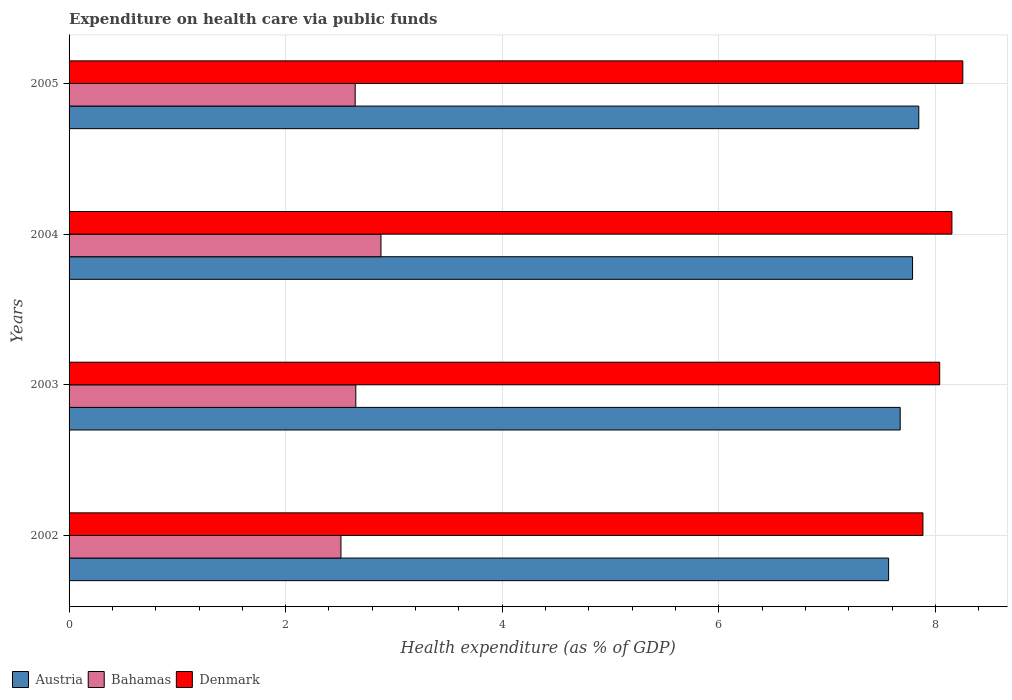How many groups of bars are there?
Give a very brief answer. 4. Are the number of bars per tick equal to the number of legend labels?
Make the answer very short. Yes. Are the number of bars on each tick of the Y-axis equal?
Ensure brevity in your answer.  Yes. How many bars are there on the 4th tick from the bottom?
Your answer should be very brief. 3. In how many cases, is the number of bars for a given year not equal to the number of legend labels?
Make the answer very short. 0. What is the expenditure made on health care in Denmark in 2002?
Offer a terse response. 7.89. Across all years, what is the maximum expenditure made on health care in Austria?
Your answer should be compact. 7.85. Across all years, what is the minimum expenditure made on health care in Denmark?
Provide a succinct answer. 7.89. In which year was the expenditure made on health care in Denmark minimum?
Provide a succinct answer. 2002. What is the total expenditure made on health care in Bahamas in the graph?
Your answer should be very brief. 10.68. What is the difference between the expenditure made on health care in Bahamas in 2004 and that in 2005?
Provide a succinct answer. 0.24. What is the difference between the expenditure made on health care in Bahamas in 2004 and the expenditure made on health care in Denmark in 2002?
Your response must be concise. -5. What is the average expenditure made on health care in Denmark per year?
Your answer should be very brief. 8.08. In the year 2005, what is the difference between the expenditure made on health care in Denmark and expenditure made on health care in Austria?
Your answer should be compact. 0.41. What is the ratio of the expenditure made on health care in Austria in 2002 to that in 2004?
Ensure brevity in your answer.  0.97. Is the expenditure made on health care in Denmark in 2002 less than that in 2005?
Your response must be concise. Yes. What is the difference between the highest and the second highest expenditure made on health care in Denmark?
Offer a very short reply. 0.1. What is the difference between the highest and the lowest expenditure made on health care in Denmark?
Provide a short and direct response. 0.37. What does the 2nd bar from the top in 2005 represents?
Your answer should be compact. Bahamas. What does the 2nd bar from the bottom in 2005 represents?
Keep it short and to the point. Bahamas. Is it the case that in every year, the sum of the expenditure made on health care in Denmark and expenditure made on health care in Bahamas is greater than the expenditure made on health care in Austria?
Your answer should be very brief. Yes. What is the difference between two consecutive major ticks on the X-axis?
Ensure brevity in your answer.  2. Are the values on the major ticks of X-axis written in scientific E-notation?
Your response must be concise. No. Does the graph contain grids?
Your answer should be very brief. Yes. Where does the legend appear in the graph?
Make the answer very short. Bottom left. How many legend labels are there?
Your answer should be very brief. 3. How are the legend labels stacked?
Keep it short and to the point. Horizontal. What is the title of the graph?
Give a very brief answer. Expenditure on health care via public funds. What is the label or title of the X-axis?
Offer a very short reply. Health expenditure (as % of GDP). What is the Health expenditure (as % of GDP) of Austria in 2002?
Give a very brief answer. 7.57. What is the Health expenditure (as % of GDP) of Bahamas in 2002?
Offer a terse response. 2.51. What is the Health expenditure (as % of GDP) of Denmark in 2002?
Offer a terse response. 7.89. What is the Health expenditure (as % of GDP) of Austria in 2003?
Your answer should be compact. 7.68. What is the Health expenditure (as % of GDP) in Bahamas in 2003?
Your answer should be very brief. 2.65. What is the Health expenditure (as % of GDP) of Denmark in 2003?
Ensure brevity in your answer.  8.04. What is the Health expenditure (as % of GDP) of Austria in 2004?
Your answer should be compact. 7.79. What is the Health expenditure (as % of GDP) in Bahamas in 2004?
Ensure brevity in your answer.  2.88. What is the Health expenditure (as % of GDP) of Denmark in 2004?
Your response must be concise. 8.15. What is the Health expenditure (as % of GDP) in Austria in 2005?
Make the answer very short. 7.85. What is the Health expenditure (as % of GDP) in Bahamas in 2005?
Keep it short and to the point. 2.64. What is the Health expenditure (as % of GDP) of Denmark in 2005?
Your answer should be very brief. 8.25. Across all years, what is the maximum Health expenditure (as % of GDP) in Austria?
Provide a short and direct response. 7.85. Across all years, what is the maximum Health expenditure (as % of GDP) in Bahamas?
Make the answer very short. 2.88. Across all years, what is the maximum Health expenditure (as % of GDP) of Denmark?
Offer a terse response. 8.25. Across all years, what is the minimum Health expenditure (as % of GDP) of Austria?
Give a very brief answer. 7.57. Across all years, what is the minimum Health expenditure (as % of GDP) in Bahamas?
Ensure brevity in your answer.  2.51. Across all years, what is the minimum Health expenditure (as % of GDP) in Denmark?
Provide a short and direct response. 7.89. What is the total Health expenditure (as % of GDP) of Austria in the graph?
Your response must be concise. 30.88. What is the total Health expenditure (as % of GDP) in Bahamas in the graph?
Make the answer very short. 10.68. What is the total Health expenditure (as % of GDP) in Denmark in the graph?
Your answer should be very brief. 32.33. What is the difference between the Health expenditure (as % of GDP) in Austria in 2002 and that in 2003?
Your answer should be very brief. -0.11. What is the difference between the Health expenditure (as % of GDP) of Bahamas in 2002 and that in 2003?
Offer a very short reply. -0.14. What is the difference between the Health expenditure (as % of GDP) in Denmark in 2002 and that in 2003?
Provide a short and direct response. -0.15. What is the difference between the Health expenditure (as % of GDP) of Austria in 2002 and that in 2004?
Offer a very short reply. -0.22. What is the difference between the Health expenditure (as % of GDP) of Bahamas in 2002 and that in 2004?
Ensure brevity in your answer.  -0.37. What is the difference between the Health expenditure (as % of GDP) in Denmark in 2002 and that in 2004?
Your answer should be very brief. -0.27. What is the difference between the Health expenditure (as % of GDP) of Austria in 2002 and that in 2005?
Keep it short and to the point. -0.28. What is the difference between the Health expenditure (as % of GDP) in Bahamas in 2002 and that in 2005?
Provide a short and direct response. -0.13. What is the difference between the Health expenditure (as % of GDP) of Denmark in 2002 and that in 2005?
Your response must be concise. -0.37. What is the difference between the Health expenditure (as % of GDP) of Austria in 2003 and that in 2004?
Provide a short and direct response. -0.11. What is the difference between the Health expenditure (as % of GDP) in Bahamas in 2003 and that in 2004?
Offer a terse response. -0.23. What is the difference between the Health expenditure (as % of GDP) of Denmark in 2003 and that in 2004?
Offer a very short reply. -0.11. What is the difference between the Health expenditure (as % of GDP) in Austria in 2003 and that in 2005?
Offer a terse response. -0.17. What is the difference between the Health expenditure (as % of GDP) of Bahamas in 2003 and that in 2005?
Provide a short and direct response. 0.01. What is the difference between the Health expenditure (as % of GDP) of Denmark in 2003 and that in 2005?
Make the answer very short. -0.21. What is the difference between the Health expenditure (as % of GDP) in Austria in 2004 and that in 2005?
Give a very brief answer. -0.06. What is the difference between the Health expenditure (as % of GDP) of Bahamas in 2004 and that in 2005?
Your response must be concise. 0.24. What is the difference between the Health expenditure (as % of GDP) of Denmark in 2004 and that in 2005?
Give a very brief answer. -0.1. What is the difference between the Health expenditure (as % of GDP) of Austria in 2002 and the Health expenditure (as % of GDP) of Bahamas in 2003?
Offer a terse response. 4.92. What is the difference between the Health expenditure (as % of GDP) in Austria in 2002 and the Health expenditure (as % of GDP) in Denmark in 2003?
Provide a succinct answer. -0.47. What is the difference between the Health expenditure (as % of GDP) of Bahamas in 2002 and the Health expenditure (as % of GDP) of Denmark in 2003?
Provide a succinct answer. -5.53. What is the difference between the Health expenditure (as % of GDP) in Austria in 2002 and the Health expenditure (as % of GDP) in Bahamas in 2004?
Your response must be concise. 4.69. What is the difference between the Health expenditure (as % of GDP) in Austria in 2002 and the Health expenditure (as % of GDP) in Denmark in 2004?
Give a very brief answer. -0.58. What is the difference between the Health expenditure (as % of GDP) of Bahamas in 2002 and the Health expenditure (as % of GDP) of Denmark in 2004?
Offer a terse response. -5.64. What is the difference between the Health expenditure (as % of GDP) of Austria in 2002 and the Health expenditure (as % of GDP) of Bahamas in 2005?
Provide a short and direct response. 4.93. What is the difference between the Health expenditure (as % of GDP) of Austria in 2002 and the Health expenditure (as % of GDP) of Denmark in 2005?
Make the answer very short. -0.69. What is the difference between the Health expenditure (as % of GDP) in Bahamas in 2002 and the Health expenditure (as % of GDP) in Denmark in 2005?
Keep it short and to the point. -5.74. What is the difference between the Health expenditure (as % of GDP) of Austria in 2003 and the Health expenditure (as % of GDP) of Bahamas in 2004?
Your response must be concise. 4.79. What is the difference between the Health expenditure (as % of GDP) in Austria in 2003 and the Health expenditure (as % of GDP) in Denmark in 2004?
Make the answer very short. -0.48. What is the difference between the Health expenditure (as % of GDP) of Bahamas in 2003 and the Health expenditure (as % of GDP) of Denmark in 2004?
Offer a terse response. -5.5. What is the difference between the Health expenditure (as % of GDP) in Austria in 2003 and the Health expenditure (as % of GDP) in Bahamas in 2005?
Your answer should be compact. 5.03. What is the difference between the Health expenditure (as % of GDP) of Austria in 2003 and the Health expenditure (as % of GDP) of Denmark in 2005?
Your answer should be very brief. -0.58. What is the difference between the Health expenditure (as % of GDP) in Bahamas in 2003 and the Health expenditure (as % of GDP) in Denmark in 2005?
Your answer should be compact. -5.61. What is the difference between the Health expenditure (as % of GDP) of Austria in 2004 and the Health expenditure (as % of GDP) of Bahamas in 2005?
Give a very brief answer. 5.15. What is the difference between the Health expenditure (as % of GDP) in Austria in 2004 and the Health expenditure (as % of GDP) in Denmark in 2005?
Your answer should be compact. -0.46. What is the difference between the Health expenditure (as % of GDP) of Bahamas in 2004 and the Health expenditure (as % of GDP) of Denmark in 2005?
Your answer should be very brief. -5.37. What is the average Health expenditure (as % of GDP) in Austria per year?
Give a very brief answer. 7.72. What is the average Health expenditure (as % of GDP) of Bahamas per year?
Provide a succinct answer. 2.67. What is the average Health expenditure (as % of GDP) of Denmark per year?
Your answer should be compact. 8.08. In the year 2002, what is the difference between the Health expenditure (as % of GDP) of Austria and Health expenditure (as % of GDP) of Bahamas?
Keep it short and to the point. 5.06. In the year 2002, what is the difference between the Health expenditure (as % of GDP) of Austria and Health expenditure (as % of GDP) of Denmark?
Your answer should be very brief. -0.32. In the year 2002, what is the difference between the Health expenditure (as % of GDP) in Bahamas and Health expenditure (as % of GDP) in Denmark?
Ensure brevity in your answer.  -5.37. In the year 2003, what is the difference between the Health expenditure (as % of GDP) in Austria and Health expenditure (as % of GDP) in Bahamas?
Offer a very short reply. 5.03. In the year 2003, what is the difference between the Health expenditure (as % of GDP) of Austria and Health expenditure (as % of GDP) of Denmark?
Keep it short and to the point. -0.36. In the year 2003, what is the difference between the Health expenditure (as % of GDP) of Bahamas and Health expenditure (as % of GDP) of Denmark?
Offer a terse response. -5.39. In the year 2004, what is the difference between the Health expenditure (as % of GDP) of Austria and Health expenditure (as % of GDP) of Bahamas?
Provide a succinct answer. 4.91. In the year 2004, what is the difference between the Health expenditure (as % of GDP) in Austria and Health expenditure (as % of GDP) in Denmark?
Offer a very short reply. -0.36. In the year 2004, what is the difference between the Health expenditure (as % of GDP) of Bahamas and Health expenditure (as % of GDP) of Denmark?
Provide a succinct answer. -5.27. In the year 2005, what is the difference between the Health expenditure (as % of GDP) in Austria and Health expenditure (as % of GDP) in Bahamas?
Give a very brief answer. 5.2. In the year 2005, what is the difference between the Health expenditure (as % of GDP) of Austria and Health expenditure (as % of GDP) of Denmark?
Keep it short and to the point. -0.41. In the year 2005, what is the difference between the Health expenditure (as % of GDP) in Bahamas and Health expenditure (as % of GDP) in Denmark?
Your answer should be compact. -5.61. What is the ratio of the Health expenditure (as % of GDP) of Austria in 2002 to that in 2003?
Make the answer very short. 0.99. What is the ratio of the Health expenditure (as % of GDP) of Bahamas in 2002 to that in 2003?
Offer a terse response. 0.95. What is the ratio of the Health expenditure (as % of GDP) of Denmark in 2002 to that in 2003?
Provide a succinct answer. 0.98. What is the ratio of the Health expenditure (as % of GDP) of Austria in 2002 to that in 2004?
Your response must be concise. 0.97. What is the ratio of the Health expenditure (as % of GDP) of Bahamas in 2002 to that in 2004?
Your answer should be very brief. 0.87. What is the ratio of the Health expenditure (as % of GDP) of Denmark in 2002 to that in 2004?
Provide a short and direct response. 0.97. What is the ratio of the Health expenditure (as % of GDP) in Austria in 2002 to that in 2005?
Provide a short and direct response. 0.96. What is the ratio of the Health expenditure (as % of GDP) of Bahamas in 2002 to that in 2005?
Make the answer very short. 0.95. What is the ratio of the Health expenditure (as % of GDP) in Denmark in 2002 to that in 2005?
Provide a succinct answer. 0.96. What is the ratio of the Health expenditure (as % of GDP) of Austria in 2003 to that in 2004?
Offer a very short reply. 0.99. What is the ratio of the Health expenditure (as % of GDP) of Bahamas in 2003 to that in 2004?
Ensure brevity in your answer.  0.92. What is the ratio of the Health expenditure (as % of GDP) of Denmark in 2003 to that in 2004?
Give a very brief answer. 0.99. What is the ratio of the Health expenditure (as % of GDP) of Austria in 2003 to that in 2005?
Offer a very short reply. 0.98. What is the ratio of the Health expenditure (as % of GDP) of Denmark in 2003 to that in 2005?
Offer a terse response. 0.97. What is the ratio of the Health expenditure (as % of GDP) of Austria in 2004 to that in 2005?
Provide a succinct answer. 0.99. What is the ratio of the Health expenditure (as % of GDP) in Bahamas in 2004 to that in 2005?
Ensure brevity in your answer.  1.09. What is the difference between the highest and the second highest Health expenditure (as % of GDP) of Austria?
Provide a short and direct response. 0.06. What is the difference between the highest and the second highest Health expenditure (as % of GDP) of Bahamas?
Provide a short and direct response. 0.23. What is the difference between the highest and the second highest Health expenditure (as % of GDP) of Denmark?
Give a very brief answer. 0.1. What is the difference between the highest and the lowest Health expenditure (as % of GDP) in Austria?
Offer a terse response. 0.28. What is the difference between the highest and the lowest Health expenditure (as % of GDP) of Bahamas?
Provide a succinct answer. 0.37. What is the difference between the highest and the lowest Health expenditure (as % of GDP) in Denmark?
Provide a short and direct response. 0.37. 